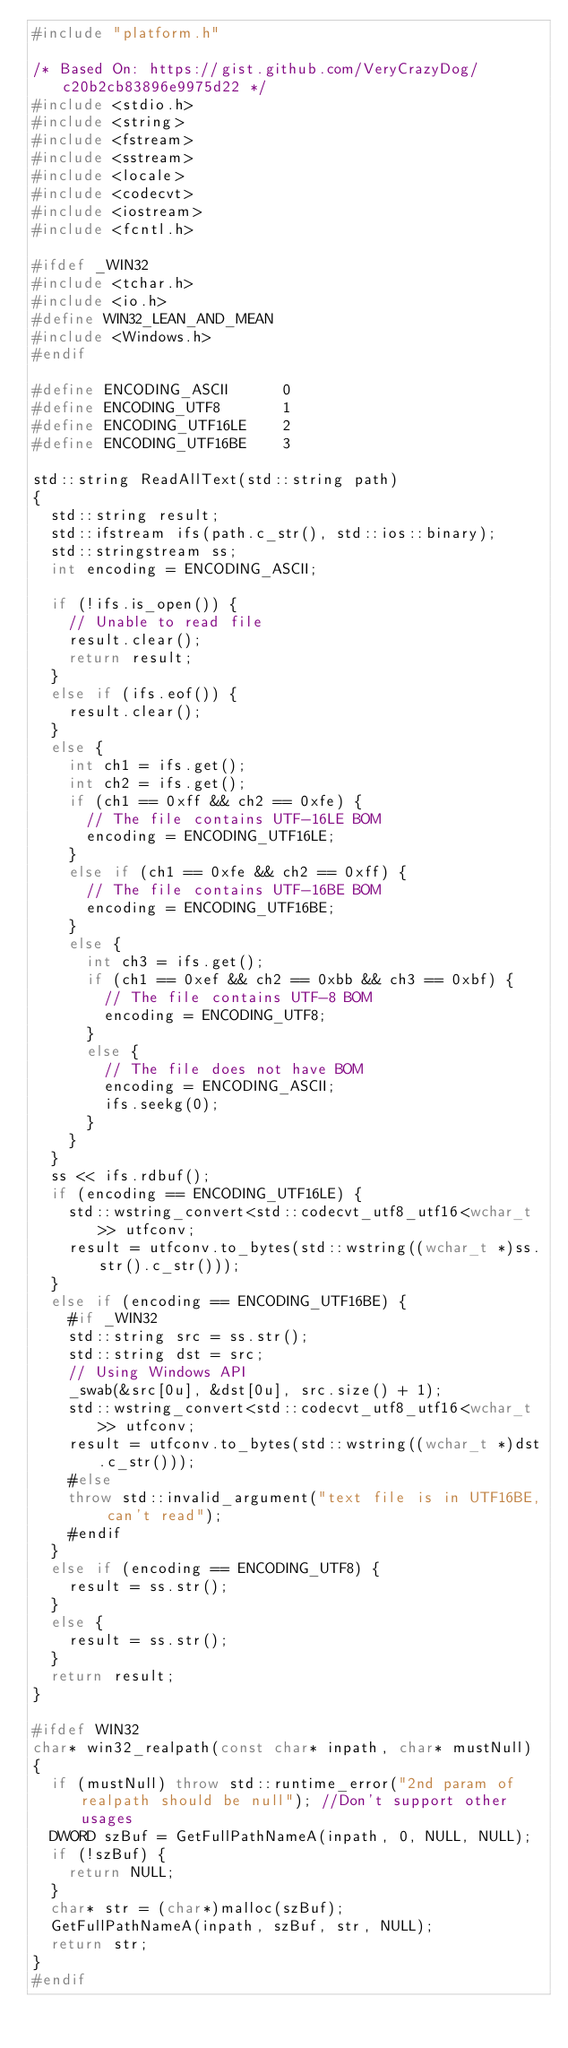<code> <loc_0><loc_0><loc_500><loc_500><_C++_>#include "platform.h"

/* Based On: https://gist.github.com/VeryCrazyDog/c20b2cb83896e9975d22 */
#include <stdio.h>
#include <string>
#include <fstream>
#include <sstream>
#include <locale>
#include <codecvt>
#include <iostream>
#include <fcntl.h>

#ifdef _WIN32
#include <tchar.h>
#include <io.h>
#define WIN32_LEAN_AND_MEAN
#include <Windows.h>
#endif

#define ENCODING_ASCII      0
#define ENCODING_UTF8       1
#define ENCODING_UTF16LE    2
#define ENCODING_UTF16BE    3

std::string ReadAllText(std::string path)
{
	std::string result;
	std::ifstream ifs(path.c_str(), std::ios::binary);
	std::stringstream ss;
	int encoding = ENCODING_ASCII;

	if (!ifs.is_open()) {
		// Unable to read file
		result.clear();
		return result;
	}
	else if (ifs.eof()) {
		result.clear();
	}
	else {
		int ch1 = ifs.get();
		int ch2 = ifs.get();
		if (ch1 == 0xff && ch2 == 0xfe) {
			// The file contains UTF-16LE BOM
			encoding = ENCODING_UTF16LE;
		}
		else if (ch1 == 0xfe && ch2 == 0xff) {
			// The file contains UTF-16BE BOM
			encoding = ENCODING_UTF16BE;
		}
		else {
			int ch3 = ifs.get();
			if (ch1 == 0xef && ch2 == 0xbb && ch3 == 0xbf) {
				// The file contains UTF-8 BOM
				encoding = ENCODING_UTF8;
			}
			else {
				// The file does not have BOM
				encoding = ENCODING_ASCII;
				ifs.seekg(0);
			}
		}
	}
	ss << ifs.rdbuf();
	if (encoding == ENCODING_UTF16LE) {
		std::wstring_convert<std::codecvt_utf8_utf16<wchar_t>> utfconv;
		result = utfconv.to_bytes(std::wstring((wchar_t *)ss.str().c_str()));
	}
	else if (encoding == ENCODING_UTF16BE) {
    #if _WIN32
		std::string src = ss.str();
		std::string dst = src;
		// Using Windows API
		_swab(&src[0u], &dst[0u], src.size() + 1);
		std::wstring_convert<std::codecvt_utf8_utf16<wchar_t>> utfconv;
		result = utfconv.to_bytes(std::wstring((wchar_t *)dst.c_str()));
    #else
    throw std::invalid_argument("text file is in UTF16BE, can't read");
    #endif
	}
	else if (encoding == ENCODING_UTF8) {
		result = ss.str();
	}
	else {
		result = ss.str();
	}
	return result;
}

#ifdef WIN32
char* win32_realpath(const char* inpath, char* mustNull)
{
	if (mustNull) throw std::runtime_error("2nd param of realpath should be null"); //Don't support other usages
	DWORD szBuf = GetFullPathNameA(inpath, 0, NULL, NULL);
	if (!szBuf) {
		return NULL;
	}
	char* str = (char*)malloc(szBuf);
	GetFullPathNameA(inpath, szBuf, str, NULL);
	return str;
}
#endif</code> 